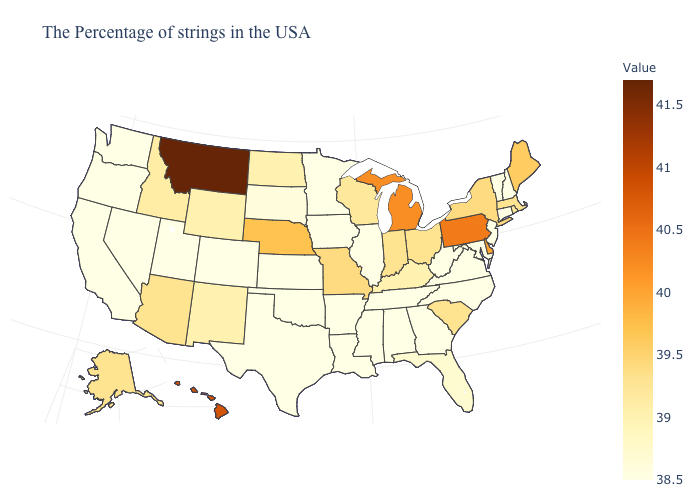Does Montana have the highest value in the USA?
Quick response, please. Yes. Among the states that border Virginia , which have the lowest value?
Be succinct. Maryland, North Carolina, West Virginia, Tennessee. Does Kentucky have the highest value in the USA?
Answer briefly. No. Among the states that border North Carolina , does Georgia have the highest value?
Be succinct. No. Does Wisconsin have a higher value than Virginia?
Keep it brief. Yes. Does New York have the lowest value in the Northeast?
Keep it brief. No. Among the states that border Utah , which have the highest value?
Quick response, please. Arizona. 